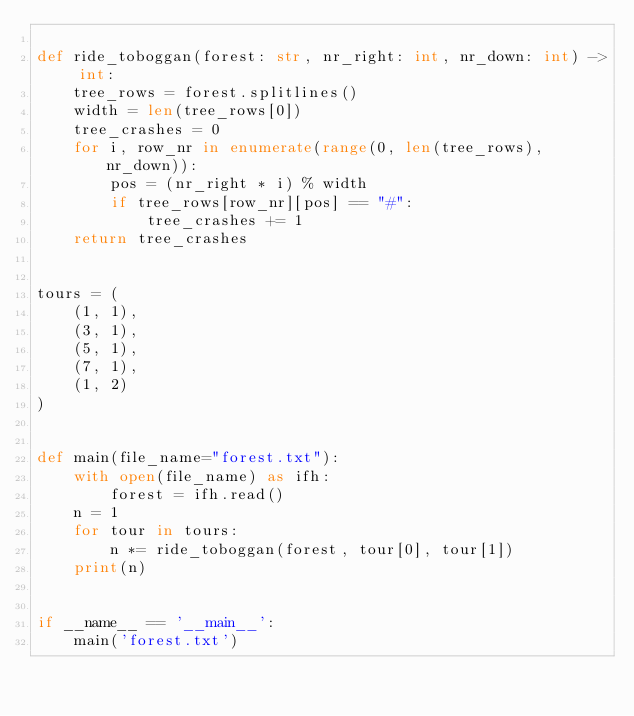Convert code to text. <code><loc_0><loc_0><loc_500><loc_500><_Python_>
def ride_toboggan(forest: str, nr_right: int, nr_down: int) -> int:
    tree_rows = forest.splitlines()
    width = len(tree_rows[0])
    tree_crashes = 0
    for i, row_nr in enumerate(range(0, len(tree_rows), nr_down)):
        pos = (nr_right * i) % width
        if tree_rows[row_nr][pos] == "#":
            tree_crashes += 1
    return tree_crashes


tours = (
    (1, 1),
    (3, 1),
    (5, 1),
    (7, 1),
    (1, 2)
)


def main(file_name="forest.txt"):
    with open(file_name) as ifh:
        forest = ifh.read()
    n = 1
    for tour in tours:
        n *= ride_toboggan(forest, tour[0], tour[1])
    print(n)


if __name__ == '__main__':
    main('forest.txt')
</code> 